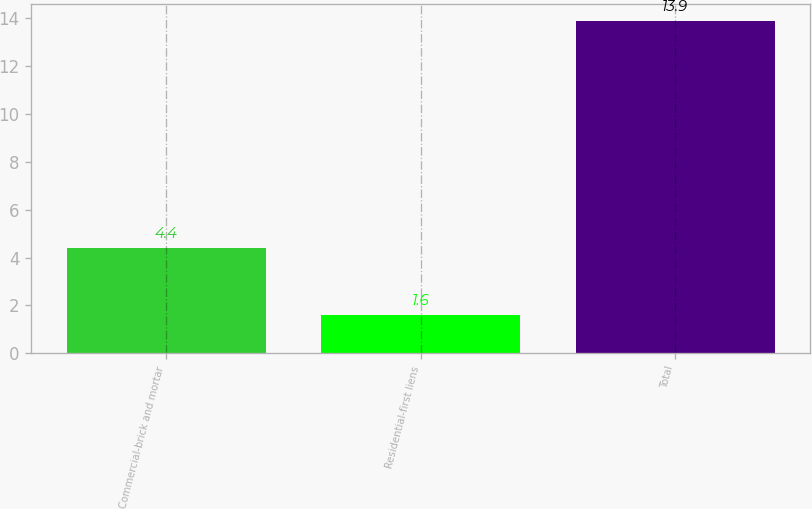<chart> <loc_0><loc_0><loc_500><loc_500><bar_chart><fcel>Commercial-brick and mortar<fcel>Residential-first liens<fcel>Total<nl><fcel>4.4<fcel>1.6<fcel>13.9<nl></chart> 